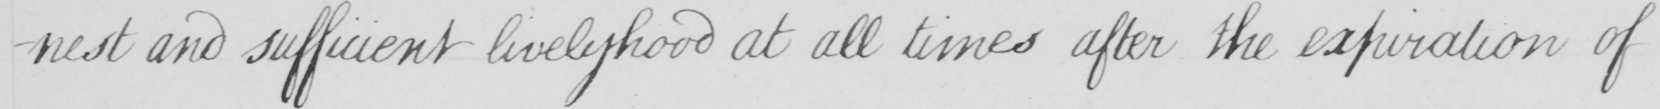Transcribe the text shown in this historical manuscript line. -nest and sufficient livelyhood at all times after the expiration of 